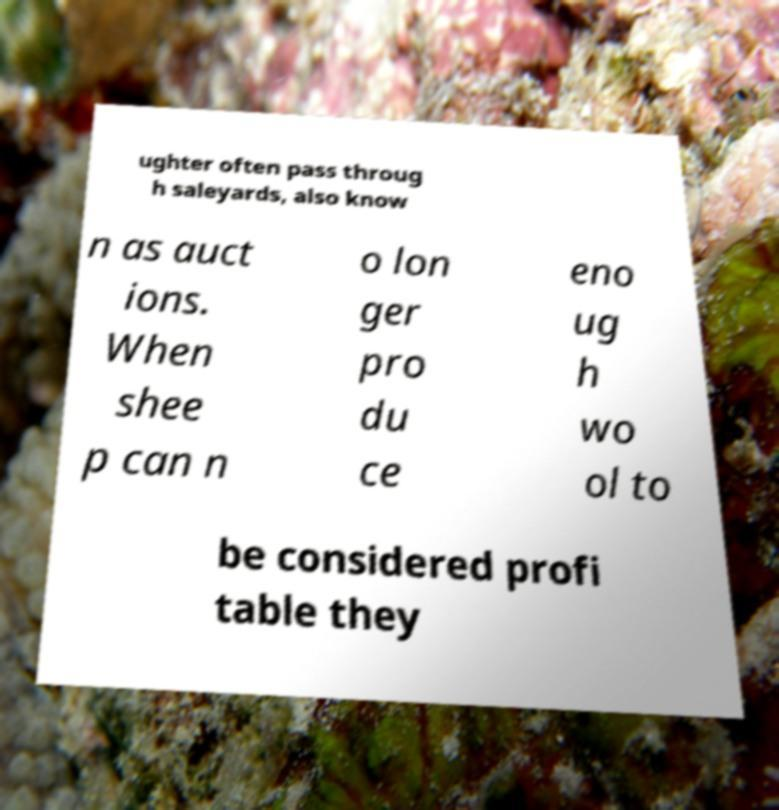Could you extract and type out the text from this image? ughter often pass throug h saleyards, also know n as auct ions. When shee p can n o lon ger pro du ce eno ug h wo ol to be considered profi table they 